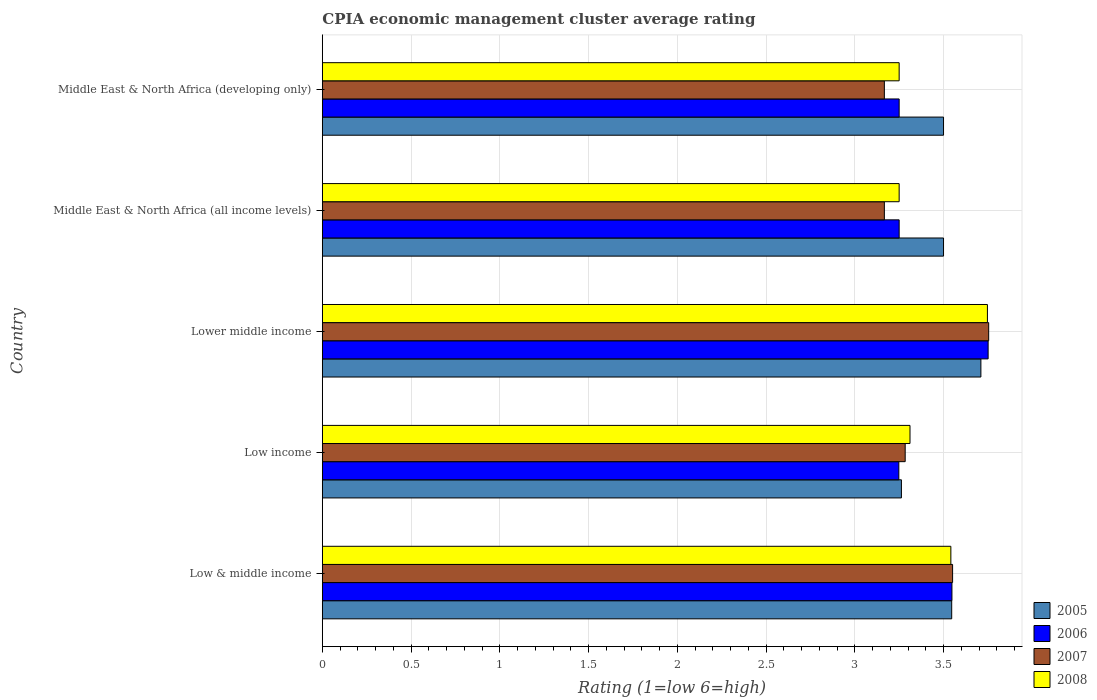How many groups of bars are there?
Your answer should be compact. 5. Are the number of bars on each tick of the Y-axis equal?
Provide a succinct answer. Yes. How many bars are there on the 2nd tick from the bottom?
Provide a short and direct response. 4. What is the label of the 3rd group of bars from the top?
Your answer should be very brief. Lower middle income. In how many cases, is the number of bars for a given country not equal to the number of legend labels?
Ensure brevity in your answer.  0. What is the CPIA rating in 2008 in Low & middle income?
Offer a very short reply. 3.54. Across all countries, what is the maximum CPIA rating in 2005?
Your answer should be compact. 3.71. In which country was the CPIA rating in 2006 maximum?
Provide a succinct answer. Lower middle income. What is the total CPIA rating in 2006 in the graph?
Provide a short and direct response. 17.05. What is the difference between the CPIA rating in 2007 in Lower middle income and the CPIA rating in 2005 in Middle East & North Africa (all income levels)?
Your answer should be very brief. 0.25. What is the average CPIA rating in 2005 per country?
Your answer should be compact. 3.5. What is the difference between the CPIA rating in 2006 and CPIA rating in 2005 in Low & middle income?
Offer a very short reply. 0. In how many countries, is the CPIA rating in 2005 greater than 0.9 ?
Give a very brief answer. 5. What is the ratio of the CPIA rating in 2008 in Lower middle income to that in Middle East & North Africa (developing only)?
Ensure brevity in your answer.  1.15. What is the difference between the highest and the second highest CPIA rating in 2005?
Keep it short and to the point. 0.16. What is the difference between the highest and the lowest CPIA rating in 2005?
Give a very brief answer. 0.45. What does the 4th bar from the top in Lower middle income represents?
Keep it short and to the point. 2005. What does the 1st bar from the bottom in Lower middle income represents?
Keep it short and to the point. 2005. Is it the case that in every country, the sum of the CPIA rating in 2007 and CPIA rating in 2008 is greater than the CPIA rating in 2005?
Offer a very short reply. Yes. Are all the bars in the graph horizontal?
Ensure brevity in your answer.  Yes. How many countries are there in the graph?
Offer a terse response. 5. What is the difference between two consecutive major ticks on the X-axis?
Offer a terse response. 0.5. Does the graph contain any zero values?
Offer a terse response. No. What is the title of the graph?
Ensure brevity in your answer.  CPIA economic management cluster average rating. What is the label or title of the X-axis?
Keep it short and to the point. Rating (1=low 6=high). What is the label or title of the Y-axis?
Ensure brevity in your answer.  Country. What is the Rating (1=low 6=high) of 2005 in Low & middle income?
Your response must be concise. 3.55. What is the Rating (1=low 6=high) in 2006 in Low & middle income?
Provide a short and direct response. 3.55. What is the Rating (1=low 6=high) of 2007 in Low & middle income?
Your answer should be very brief. 3.55. What is the Rating (1=low 6=high) of 2008 in Low & middle income?
Offer a terse response. 3.54. What is the Rating (1=low 6=high) of 2005 in Low income?
Your answer should be compact. 3.26. What is the Rating (1=low 6=high) in 2006 in Low income?
Offer a terse response. 3.25. What is the Rating (1=low 6=high) of 2007 in Low income?
Give a very brief answer. 3.28. What is the Rating (1=low 6=high) in 2008 in Low income?
Provide a short and direct response. 3.31. What is the Rating (1=low 6=high) in 2005 in Lower middle income?
Ensure brevity in your answer.  3.71. What is the Rating (1=low 6=high) of 2006 in Lower middle income?
Provide a succinct answer. 3.75. What is the Rating (1=low 6=high) in 2007 in Lower middle income?
Offer a terse response. 3.75. What is the Rating (1=low 6=high) of 2008 in Lower middle income?
Your response must be concise. 3.75. What is the Rating (1=low 6=high) in 2005 in Middle East & North Africa (all income levels)?
Ensure brevity in your answer.  3.5. What is the Rating (1=low 6=high) of 2006 in Middle East & North Africa (all income levels)?
Your answer should be compact. 3.25. What is the Rating (1=low 6=high) in 2007 in Middle East & North Africa (all income levels)?
Make the answer very short. 3.17. What is the Rating (1=low 6=high) in 2005 in Middle East & North Africa (developing only)?
Make the answer very short. 3.5. What is the Rating (1=low 6=high) of 2007 in Middle East & North Africa (developing only)?
Your answer should be very brief. 3.17. What is the Rating (1=low 6=high) of 2008 in Middle East & North Africa (developing only)?
Ensure brevity in your answer.  3.25. Across all countries, what is the maximum Rating (1=low 6=high) of 2005?
Ensure brevity in your answer.  3.71. Across all countries, what is the maximum Rating (1=low 6=high) of 2006?
Keep it short and to the point. 3.75. Across all countries, what is the maximum Rating (1=low 6=high) of 2007?
Keep it short and to the point. 3.75. Across all countries, what is the maximum Rating (1=low 6=high) in 2008?
Keep it short and to the point. 3.75. Across all countries, what is the minimum Rating (1=low 6=high) of 2005?
Your answer should be compact. 3.26. Across all countries, what is the minimum Rating (1=low 6=high) in 2006?
Your answer should be compact. 3.25. Across all countries, what is the minimum Rating (1=low 6=high) in 2007?
Offer a very short reply. 3.17. What is the total Rating (1=low 6=high) in 2005 in the graph?
Provide a short and direct response. 17.52. What is the total Rating (1=low 6=high) of 2006 in the graph?
Offer a terse response. 17.05. What is the total Rating (1=low 6=high) in 2007 in the graph?
Provide a short and direct response. 16.92. What is the total Rating (1=low 6=high) in 2008 in the graph?
Your answer should be very brief. 17.1. What is the difference between the Rating (1=low 6=high) in 2005 in Low & middle income and that in Low income?
Your answer should be very brief. 0.28. What is the difference between the Rating (1=low 6=high) in 2006 in Low & middle income and that in Low income?
Your answer should be very brief. 0.3. What is the difference between the Rating (1=low 6=high) in 2007 in Low & middle income and that in Low income?
Make the answer very short. 0.27. What is the difference between the Rating (1=low 6=high) in 2008 in Low & middle income and that in Low income?
Keep it short and to the point. 0.23. What is the difference between the Rating (1=low 6=high) of 2005 in Low & middle income and that in Lower middle income?
Offer a terse response. -0.16. What is the difference between the Rating (1=low 6=high) in 2006 in Low & middle income and that in Lower middle income?
Offer a very short reply. -0.2. What is the difference between the Rating (1=low 6=high) in 2007 in Low & middle income and that in Lower middle income?
Provide a short and direct response. -0.2. What is the difference between the Rating (1=low 6=high) in 2008 in Low & middle income and that in Lower middle income?
Offer a terse response. -0.21. What is the difference between the Rating (1=low 6=high) in 2005 in Low & middle income and that in Middle East & North Africa (all income levels)?
Give a very brief answer. 0.05. What is the difference between the Rating (1=low 6=high) in 2006 in Low & middle income and that in Middle East & North Africa (all income levels)?
Provide a short and direct response. 0.3. What is the difference between the Rating (1=low 6=high) in 2007 in Low & middle income and that in Middle East & North Africa (all income levels)?
Give a very brief answer. 0.38. What is the difference between the Rating (1=low 6=high) of 2008 in Low & middle income and that in Middle East & North Africa (all income levels)?
Keep it short and to the point. 0.29. What is the difference between the Rating (1=low 6=high) in 2005 in Low & middle income and that in Middle East & North Africa (developing only)?
Keep it short and to the point. 0.05. What is the difference between the Rating (1=low 6=high) of 2006 in Low & middle income and that in Middle East & North Africa (developing only)?
Offer a terse response. 0.3. What is the difference between the Rating (1=low 6=high) of 2007 in Low & middle income and that in Middle East & North Africa (developing only)?
Give a very brief answer. 0.38. What is the difference between the Rating (1=low 6=high) of 2008 in Low & middle income and that in Middle East & North Africa (developing only)?
Your response must be concise. 0.29. What is the difference between the Rating (1=low 6=high) in 2005 in Low income and that in Lower middle income?
Offer a very short reply. -0.45. What is the difference between the Rating (1=low 6=high) in 2006 in Low income and that in Lower middle income?
Your answer should be compact. -0.5. What is the difference between the Rating (1=low 6=high) in 2007 in Low income and that in Lower middle income?
Your answer should be compact. -0.47. What is the difference between the Rating (1=low 6=high) of 2008 in Low income and that in Lower middle income?
Offer a very short reply. -0.44. What is the difference between the Rating (1=low 6=high) of 2005 in Low income and that in Middle East & North Africa (all income levels)?
Your answer should be compact. -0.24. What is the difference between the Rating (1=low 6=high) in 2006 in Low income and that in Middle East & North Africa (all income levels)?
Ensure brevity in your answer.  -0. What is the difference between the Rating (1=low 6=high) of 2007 in Low income and that in Middle East & North Africa (all income levels)?
Provide a succinct answer. 0.12. What is the difference between the Rating (1=low 6=high) of 2008 in Low income and that in Middle East & North Africa (all income levels)?
Ensure brevity in your answer.  0.06. What is the difference between the Rating (1=low 6=high) in 2005 in Low income and that in Middle East & North Africa (developing only)?
Your answer should be compact. -0.24. What is the difference between the Rating (1=low 6=high) in 2006 in Low income and that in Middle East & North Africa (developing only)?
Ensure brevity in your answer.  -0. What is the difference between the Rating (1=low 6=high) of 2007 in Low income and that in Middle East & North Africa (developing only)?
Give a very brief answer. 0.12. What is the difference between the Rating (1=low 6=high) in 2008 in Low income and that in Middle East & North Africa (developing only)?
Offer a terse response. 0.06. What is the difference between the Rating (1=low 6=high) of 2005 in Lower middle income and that in Middle East & North Africa (all income levels)?
Provide a short and direct response. 0.21. What is the difference between the Rating (1=low 6=high) in 2006 in Lower middle income and that in Middle East & North Africa (all income levels)?
Offer a terse response. 0.5. What is the difference between the Rating (1=low 6=high) in 2007 in Lower middle income and that in Middle East & North Africa (all income levels)?
Provide a short and direct response. 0.59. What is the difference between the Rating (1=low 6=high) of 2008 in Lower middle income and that in Middle East & North Africa (all income levels)?
Your answer should be compact. 0.5. What is the difference between the Rating (1=low 6=high) in 2005 in Lower middle income and that in Middle East & North Africa (developing only)?
Give a very brief answer. 0.21. What is the difference between the Rating (1=low 6=high) of 2006 in Lower middle income and that in Middle East & North Africa (developing only)?
Your answer should be compact. 0.5. What is the difference between the Rating (1=low 6=high) of 2007 in Lower middle income and that in Middle East & North Africa (developing only)?
Your answer should be compact. 0.59. What is the difference between the Rating (1=low 6=high) of 2008 in Lower middle income and that in Middle East & North Africa (developing only)?
Keep it short and to the point. 0.5. What is the difference between the Rating (1=low 6=high) in 2005 in Middle East & North Africa (all income levels) and that in Middle East & North Africa (developing only)?
Provide a succinct answer. 0. What is the difference between the Rating (1=low 6=high) in 2007 in Middle East & North Africa (all income levels) and that in Middle East & North Africa (developing only)?
Offer a very short reply. 0. What is the difference between the Rating (1=low 6=high) of 2005 in Low & middle income and the Rating (1=low 6=high) of 2006 in Low income?
Your answer should be compact. 0.3. What is the difference between the Rating (1=low 6=high) of 2005 in Low & middle income and the Rating (1=low 6=high) of 2007 in Low income?
Make the answer very short. 0.26. What is the difference between the Rating (1=low 6=high) of 2005 in Low & middle income and the Rating (1=low 6=high) of 2008 in Low income?
Make the answer very short. 0.23. What is the difference between the Rating (1=low 6=high) of 2006 in Low & middle income and the Rating (1=low 6=high) of 2007 in Low income?
Your answer should be very brief. 0.26. What is the difference between the Rating (1=low 6=high) in 2006 in Low & middle income and the Rating (1=low 6=high) in 2008 in Low income?
Keep it short and to the point. 0.24. What is the difference between the Rating (1=low 6=high) of 2007 in Low & middle income and the Rating (1=low 6=high) of 2008 in Low income?
Make the answer very short. 0.24. What is the difference between the Rating (1=low 6=high) in 2005 in Low & middle income and the Rating (1=low 6=high) in 2006 in Lower middle income?
Your answer should be very brief. -0.21. What is the difference between the Rating (1=low 6=high) of 2005 in Low & middle income and the Rating (1=low 6=high) of 2007 in Lower middle income?
Give a very brief answer. -0.21. What is the difference between the Rating (1=low 6=high) of 2005 in Low & middle income and the Rating (1=low 6=high) of 2008 in Lower middle income?
Give a very brief answer. -0.2. What is the difference between the Rating (1=low 6=high) of 2006 in Low & middle income and the Rating (1=low 6=high) of 2007 in Lower middle income?
Give a very brief answer. -0.21. What is the difference between the Rating (1=low 6=high) of 2006 in Low & middle income and the Rating (1=low 6=high) of 2008 in Lower middle income?
Your answer should be compact. -0.2. What is the difference between the Rating (1=low 6=high) in 2007 in Low & middle income and the Rating (1=low 6=high) in 2008 in Lower middle income?
Keep it short and to the point. -0.2. What is the difference between the Rating (1=low 6=high) in 2005 in Low & middle income and the Rating (1=low 6=high) in 2006 in Middle East & North Africa (all income levels)?
Provide a succinct answer. 0.3. What is the difference between the Rating (1=low 6=high) of 2005 in Low & middle income and the Rating (1=low 6=high) of 2007 in Middle East & North Africa (all income levels)?
Provide a succinct answer. 0.38. What is the difference between the Rating (1=low 6=high) of 2005 in Low & middle income and the Rating (1=low 6=high) of 2008 in Middle East & North Africa (all income levels)?
Give a very brief answer. 0.3. What is the difference between the Rating (1=low 6=high) in 2006 in Low & middle income and the Rating (1=low 6=high) in 2007 in Middle East & North Africa (all income levels)?
Your answer should be compact. 0.38. What is the difference between the Rating (1=low 6=high) in 2006 in Low & middle income and the Rating (1=low 6=high) in 2008 in Middle East & North Africa (all income levels)?
Your response must be concise. 0.3. What is the difference between the Rating (1=low 6=high) of 2007 in Low & middle income and the Rating (1=low 6=high) of 2008 in Middle East & North Africa (all income levels)?
Ensure brevity in your answer.  0.3. What is the difference between the Rating (1=low 6=high) of 2005 in Low & middle income and the Rating (1=low 6=high) of 2006 in Middle East & North Africa (developing only)?
Provide a short and direct response. 0.3. What is the difference between the Rating (1=low 6=high) in 2005 in Low & middle income and the Rating (1=low 6=high) in 2007 in Middle East & North Africa (developing only)?
Your answer should be compact. 0.38. What is the difference between the Rating (1=low 6=high) in 2005 in Low & middle income and the Rating (1=low 6=high) in 2008 in Middle East & North Africa (developing only)?
Offer a very short reply. 0.3. What is the difference between the Rating (1=low 6=high) in 2006 in Low & middle income and the Rating (1=low 6=high) in 2007 in Middle East & North Africa (developing only)?
Provide a succinct answer. 0.38. What is the difference between the Rating (1=low 6=high) in 2006 in Low & middle income and the Rating (1=low 6=high) in 2008 in Middle East & North Africa (developing only)?
Provide a succinct answer. 0.3. What is the difference between the Rating (1=low 6=high) of 2007 in Low & middle income and the Rating (1=low 6=high) of 2008 in Middle East & North Africa (developing only)?
Provide a succinct answer. 0.3. What is the difference between the Rating (1=low 6=high) in 2005 in Low income and the Rating (1=low 6=high) in 2006 in Lower middle income?
Ensure brevity in your answer.  -0.49. What is the difference between the Rating (1=low 6=high) of 2005 in Low income and the Rating (1=low 6=high) of 2007 in Lower middle income?
Keep it short and to the point. -0.49. What is the difference between the Rating (1=low 6=high) in 2005 in Low income and the Rating (1=low 6=high) in 2008 in Lower middle income?
Your answer should be compact. -0.48. What is the difference between the Rating (1=low 6=high) in 2006 in Low income and the Rating (1=low 6=high) in 2007 in Lower middle income?
Make the answer very short. -0.51. What is the difference between the Rating (1=low 6=high) of 2006 in Low income and the Rating (1=low 6=high) of 2008 in Lower middle income?
Offer a very short reply. -0.5. What is the difference between the Rating (1=low 6=high) of 2007 in Low income and the Rating (1=low 6=high) of 2008 in Lower middle income?
Provide a short and direct response. -0.46. What is the difference between the Rating (1=low 6=high) in 2005 in Low income and the Rating (1=low 6=high) in 2006 in Middle East & North Africa (all income levels)?
Ensure brevity in your answer.  0.01. What is the difference between the Rating (1=low 6=high) in 2005 in Low income and the Rating (1=low 6=high) in 2007 in Middle East & North Africa (all income levels)?
Make the answer very short. 0.1. What is the difference between the Rating (1=low 6=high) in 2005 in Low income and the Rating (1=low 6=high) in 2008 in Middle East & North Africa (all income levels)?
Ensure brevity in your answer.  0.01. What is the difference between the Rating (1=low 6=high) in 2006 in Low income and the Rating (1=low 6=high) in 2007 in Middle East & North Africa (all income levels)?
Provide a succinct answer. 0.08. What is the difference between the Rating (1=low 6=high) of 2006 in Low income and the Rating (1=low 6=high) of 2008 in Middle East & North Africa (all income levels)?
Ensure brevity in your answer.  -0. What is the difference between the Rating (1=low 6=high) in 2007 in Low income and the Rating (1=low 6=high) in 2008 in Middle East & North Africa (all income levels)?
Provide a succinct answer. 0.03. What is the difference between the Rating (1=low 6=high) of 2005 in Low income and the Rating (1=low 6=high) of 2006 in Middle East & North Africa (developing only)?
Give a very brief answer. 0.01. What is the difference between the Rating (1=low 6=high) in 2005 in Low income and the Rating (1=low 6=high) in 2007 in Middle East & North Africa (developing only)?
Make the answer very short. 0.1. What is the difference between the Rating (1=low 6=high) in 2005 in Low income and the Rating (1=low 6=high) in 2008 in Middle East & North Africa (developing only)?
Your answer should be very brief. 0.01. What is the difference between the Rating (1=low 6=high) of 2006 in Low income and the Rating (1=low 6=high) of 2007 in Middle East & North Africa (developing only)?
Your answer should be very brief. 0.08. What is the difference between the Rating (1=low 6=high) of 2006 in Low income and the Rating (1=low 6=high) of 2008 in Middle East & North Africa (developing only)?
Keep it short and to the point. -0. What is the difference between the Rating (1=low 6=high) of 2007 in Low income and the Rating (1=low 6=high) of 2008 in Middle East & North Africa (developing only)?
Offer a terse response. 0.03. What is the difference between the Rating (1=low 6=high) of 2005 in Lower middle income and the Rating (1=low 6=high) of 2006 in Middle East & North Africa (all income levels)?
Give a very brief answer. 0.46. What is the difference between the Rating (1=low 6=high) in 2005 in Lower middle income and the Rating (1=low 6=high) in 2007 in Middle East & North Africa (all income levels)?
Give a very brief answer. 0.54. What is the difference between the Rating (1=low 6=high) in 2005 in Lower middle income and the Rating (1=low 6=high) in 2008 in Middle East & North Africa (all income levels)?
Give a very brief answer. 0.46. What is the difference between the Rating (1=low 6=high) in 2006 in Lower middle income and the Rating (1=low 6=high) in 2007 in Middle East & North Africa (all income levels)?
Keep it short and to the point. 0.58. What is the difference between the Rating (1=low 6=high) of 2006 in Lower middle income and the Rating (1=low 6=high) of 2008 in Middle East & North Africa (all income levels)?
Your answer should be very brief. 0.5. What is the difference between the Rating (1=low 6=high) of 2007 in Lower middle income and the Rating (1=low 6=high) of 2008 in Middle East & North Africa (all income levels)?
Offer a terse response. 0.5. What is the difference between the Rating (1=low 6=high) of 2005 in Lower middle income and the Rating (1=low 6=high) of 2006 in Middle East & North Africa (developing only)?
Offer a very short reply. 0.46. What is the difference between the Rating (1=low 6=high) in 2005 in Lower middle income and the Rating (1=low 6=high) in 2007 in Middle East & North Africa (developing only)?
Offer a terse response. 0.54. What is the difference between the Rating (1=low 6=high) in 2005 in Lower middle income and the Rating (1=low 6=high) in 2008 in Middle East & North Africa (developing only)?
Offer a terse response. 0.46. What is the difference between the Rating (1=low 6=high) of 2006 in Lower middle income and the Rating (1=low 6=high) of 2007 in Middle East & North Africa (developing only)?
Keep it short and to the point. 0.58. What is the difference between the Rating (1=low 6=high) of 2006 in Lower middle income and the Rating (1=low 6=high) of 2008 in Middle East & North Africa (developing only)?
Keep it short and to the point. 0.5. What is the difference between the Rating (1=low 6=high) of 2007 in Lower middle income and the Rating (1=low 6=high) of 2008 in Middle East & North Africa (developing only)?
Your response must be concise. 0.5. What is the difference between the Rating (1=low 6=high) of 2005 in Middle East & North Africa (all income levels) and the Rating (1=low 6=high) of 2006 in Middle East & North Africa (developing only)?
Your answer should be very brief. 0.25. What is the difference between the Rating (1=low 6=high) of 2006 in Middle East & North Africa (all income levels) and the Rating (1=low 6=high) of 2007 in Middle East & North Africa (developing only)?
Give a very brief answer. 0.08. What is the difference between the Rating (1=low 6=high) in 2006 in Middle East & North Africa (all income levels) and the Rating (1=low 6=high) in 2008 in Middle East & North Africa (developing only)?
Keep it short and to the point. 0. What is the difference between the Rating (1=low 6=high) of 2007 in Middle East & North Africa (all income levels) and the Rating (1=low 6=high) of 2008 in Middle East & North Africa (developing only)?
Provide a succinct answer. -0.08. What is the average Rating (1=low 6=high) of 2005 per country?
Ensure brevity in your answer.  3.5. What is the average Rating (1=low 6=high) in 2006 per country?
Provide a short and direct response. 3.41. What is the average Rating (1=low 6=high) in 2007 per country?
Provide a succinct answer. 3.38. What is the average Rating (1=low 6=high) of 2008 per country?
Your response must be concise. 3.42. What is the difference between the Rating (1=low 6=high) in 2005 and Rating (1=low 6=high) in 2006 in Low & middle income?
Offer a terse response. -0. What is the difference between the Rating (1=low 6=high) of 2005 and Rating (1=low 6=high) of 2007 in Low & middle income?
Your answer should be compact. -0.01. What is the difference between the Rating (1=low 6=high) of 2005 and Rating (1=low 6=high) of 2008 in Low & middle income?
Provide a short and direct response. 0. What is the difference between the Rating (1=low 6=high) in 2006 and Rating (1=low 6=high) in 2007 in Low & middle income?
Offer a very short reply. -0. What is the difference between the Rating (1=low 6=high) of 2006 and Rating (1=low 6=high) of 2008 in Low & middle income?
Give a very brief answer. 0.01. What is the difference between the Rating (1=low 6=high) in 2007 and Rating (1=low 6=high) in 2008 in Low & middle income?
Provide a short and direct response. 0.01. What is the difference between the Rating (1=low 6=high) in 2005 and Rating (1=low 6=high) in 2006 in Low income?
Ensure brevity in your answer.  0.01. What is the difference between the Rating (1=low 6=high) in 2005 and Rating (1=low 6=high) in 2007 in Low income?
Give a very brief answer. -0.02. What is the difference between the Rating (1=low 6=high) in 2005 and Rating (1=low 6=high) in 2008 in Low income?
Make the answer very short. -0.05. What is the difference between the Rating (1=low 6=high) of 2006 and Rating (1=low 6=high) of 2007 in Low income?
Provide a succinct answer. -0.04. What is the difference between the Rating (1=low 6=high) of 2006 and Rating (1=low 6=high) of 2008 in Low income?
Your response must be concise. -0.06. What is the difference between the Rating (1=low 6=high) of 2007 and Rating (1=low 6=high) of 2008 in Low income?
Provide a succinct answer. -0.03. What is the difference between the Rating (1=low 6=high) in 2005 and Rating (1=low 6=high) in 2006 in Lower middle income?
Provide a succinct answer. -0.04. What is the difference between the Rating (1=low 6=high) in 2005 and Rating (1=low 6=high) in 2007 in Lower middle income?
Give a very brief answer. -0.04. What is the difference between the Rating (1=low 6=high) of 2005 and Rating (1=low 6=high) of 2008 in Lower middle income?
Your response must be concise. -0.04. What is the difference between the Rating (1=low 6=high) of 2006 and Rating (1=low 6=high) of 2007 in Lower middle income?
Keep it short and to the point. -0. What is the difference between the Rating (1=low 6=high) of 2006 and Rating (1=low 6=high) of 2008 in Lower middle income?
Give a very brief answer. 0. What is the difference between the Rating (1=low 6=high) of 2007 and Rating (1=low 6=high) of 2008 in Lower middle income?
Your response must be concise. 0.01. What is the difference between the Rating (1=low 6=high) in 2006 and Rating (1=low 6=high) in 2007 in Middle East & North Africa (all income levels)?
Ensure brevity in your answer.  0.08. What is the difference between the Rating (1=low 6=high) in 2006 and Rating (1=low 6=high) in 2008 in Middle East & North Africa (all income levels)?
Provide a succinct answer. 0. What is the difference between the Rating (1=low 6=high) of 2007 and Rating (1=low 6=high) of 2008 in Middle East & North Africa (all income levels)?
Your answer should be very brief. -0.08. What is the difference between the Rating (1=low 6=high) in 2005 and Rating (1=low 6=high) in 2007 in Middle East & North Africa (developing only)?
Ensure brevity in your answer.  0.33. What is the difference between the Rating (1=low 6=high) of 2006 and Rating (1=low 6=high) of 2007 in Middle East & North Africa (developing only)?
Offer a very short reply. 0.08. What is the difference between the Rating (1=low 6=high) in 2006 and Rating (1=low 6=high) in 2008 in Middle East & North Africa (developing only)?
Keep it short and to the point. 0. What is the difference between the Rating (1=low 6=high) of 2007 and Rating (1=low 6=high) of 2008 in Middle East & North Africa (developing only)?
Keep it short and to the point. -0.08. What is the ratio of the Rating (1=low 6=high) in 2005 in Low & middle income to that in Low income?
Make the answer very short. 1.09. What is the ratio of the Rating (1=low 6=high) in 2006 in Low & middle income to that in Low income?
Your response must be concise. 1.09. What is the ratio of the Rating (1=low 6=high) of 2007 in Low & middle income to that in Low income?
Offer a very short reply. 1.08. What is the ratio of the Rating (1=low 6=high) in 2008 in Low & middle income to that in Low income?
Provide a succinct answer. 1.07. What is the ratio of the Rating (1=low 6=high) in 2005 in Low & middle income to that in Lower middle income?
Make the answer very short. 0.96. What is the ratio of the Rating (1=low 6=high) in 2006 in Low & middle income to that in Lower middle income?
Offer a terse response. 0.95. What is the ratio of the Rating (1=low 6=high) in 2007 in Low & middle income to that in Lower middle income?
Provide a succinct answer. 0.95. What is the ratio of the Rating (1=low 6=high) of 2008 in Low & middle income to that in Lower middle income?
Give a very brief answer. 0.94. What is the ratio of the Rating (1=low 6=high) in 2005 in Low & middle income to that in Middle East & North Africa (all income levels)?
Keep it short and to the point. 1.01. What is the ratio of the Rating (1=low 6=high) in 2006 in Low & middle income to that in Middle East & North Africa (all income levels)?
Make the answer very short. 1.09. What is the ratio of the Rating (1=low 6=high) of 2007 in Low & middle income to that in Middle East & North Africa (all income levels)?
Your answer should be very brief. 1.12. What is the ratio of the Rating (1=low 6=high) of 2008 in Low & middle income to that in Middle East & North Africa (all income levels)?
Your answer should be compact. 1.09. What is the ratio of the Rating (1=low 6=high) of 2005 in Low & middle income to that in Middle East & North Africa (developing only)?
Offer a terse response. 1.01. What is the ratio of the Rating (1=low 6=high) in 2006 in Low & middle income to that in Middle East & North Africa (developing only)?
Your response must be concise. 1.09. What is the ratio of the Rating (1=low 6=high) in 2007 in Low & middle income to that in Middle East & North Africa (developing only)?
Give a very brief answer. 1.12. What is the ratio of the Rating (1=low 6=high) of 2008 in Low & middle income to that in Middle East & North Africa (developing only)?
Keep it short and to the point. 1.09. What is the ratio of the Rating (1=low 6=high) in 2005 in Low income to that in Lower middle income?
Your response must be concise. 0.88. What is the ratio of the Rating (1=low 6=high) of 2006 in Low income to that in Lower middle income?
Keep it short and to the point. 0.87. What is the ratio of the Rating (1=low 6=high) in 2007 in Low income to that in Lower middle income?
Provide a short and direct response. 0.87. What is the ratio of the Rating (1=low 6=high) of 2008 in Low income to that in Lower middle income?
Your response must be concise. 0.88. What is the ratio of the Rating (1=low 6=high) in 2005 in Low income to that in Middle East & North Africa (all income levels)?
Provide a short and direct response. 0.93. What is the ratio of the Rating (1=low 6=high) of 2008 in Low income to that in Middle East & North Africa (all income levels)?
Your answer should be very brief. 1.02. What is the ratio of the Rating (1=low 6=high) of 2005 in Low income to that in Middle East & North Africa (developing only)?
Give a very brief answer. 0.93. What is the ratio of the Rating (1=low 6=high) of 2006 in Low income to that in Middle East & North Africa (developing only)?
Ensure brevity in your answer.  1. What is the ratio of the Rating (1=low 6=high) in 2007 in Low income to that in Middle East & North Africa (developing only)?
Make the answer very short. 1.04. What is the ratio of the Rating (1=low 6=high) in 2008 in Low income to that in Middle East & North Africa (developing only)?
Give a very brief answer. 1.02. What is the ratio of the Rating (1=low 6=high) of 2005 in Lower middle income to that in Middle East & North Africa (all income levels)?
Make the answer very short. 1.06. What is the ratio of the Rating (1=low 6=high) in 2006 in Lower middle income to that in Middle East & North Africa (all income levels)?
Offer a terse response. 1.15. What is the ratio of the Rating (1=low 6=high) of 2007 in Lower middle income to that in Middle East & North Africa (all income levels)?
Provide a short and direct response. 1.19. What is the ratio of the Rating (1=low 6=high) in 2008 in Lower middle income to that in Middle East & North Africa (all income levels)?
Offer a terse response. 1.15. What is the ratio of the Rating (1=low 6=high) of 2005 in Lower middle income to that in Middle East & North Africa (developing only)?
Offer a terse response. 1.06. What is the ratio of the Rating (1=low 6=high) of 2006 in Lower middle income to that in Middle East & North Africa (developing only)?
Offer a very short reply. 1.15. What is the ratio of the Rating (1=low 6=high) of 2007 in Lower middle income to that in Middle East & North Africa (developing only)?
Make the answer very short. 1.19. What is the ratio of the Rating (1=low 6=high) in 2008 in Lower middle income to that in Middle East & North Africa (developing only)?
Make the answer very short. 1.15. What is the difference between the highest and the second highest Rating (1=low 6=high) in 2005?
Keep it short and to the point. 0.16. What is the difference between the highest and the second highest Rating (1=low 6=high) in 2006?
Give a very brief answer. 0.2. What is the difference between the highest and the second highest Rating (1=low 6=high) in 2007?
Your response must be concise. 0.2. What is the difference between the highest and the second highest Rating (1=low 6=high) in 2008?
Your response must be concise. 0.21. What is the difference between the highest and the lowest Rating (1=low 6=high) in 2005?
Your answer should be very brief. 0.45. What is the difference between the highest and the lowest Rating (1=low 6=high) in 2006?
Give a very brief answer. 0.5. What is the difference between the highest and the lowest Rating (1=low 6=high) in 2007?
Your answer should be compact. 0.59. What is the difference between the highest and the lowest Rating (1=low 6=high) in 2008?
Offer a terse response. 0.5. 